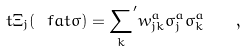Convert formula to latex. <formula><loc_0><loc_0><loc_500><loc_500>\ t { \Xi } _ { j } ( \ f a t { \sigma } ) = { \sum _ { k } } ^ { \prime } w ^ { a } _ { j k } \sigma _ { j } ^ { a } \sigma _ { k } ^ { a } \quad ,</formula> 